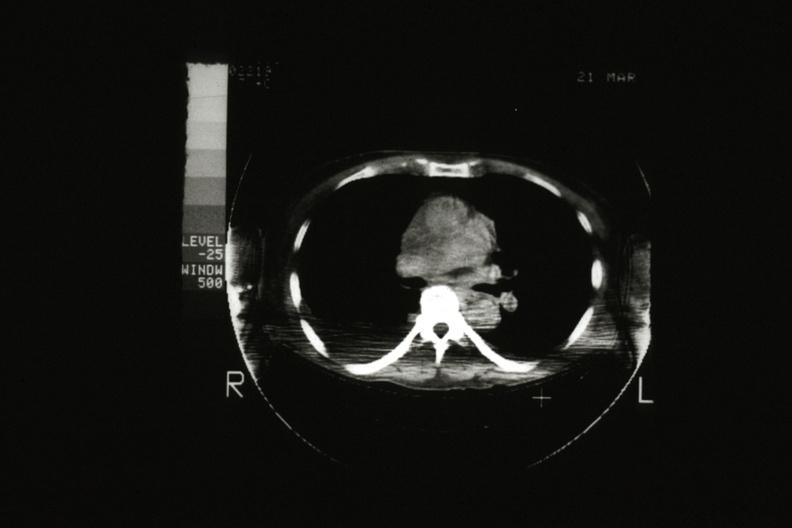s malignant thymoma present?
Answer the question using a single word or phrase. Yes 